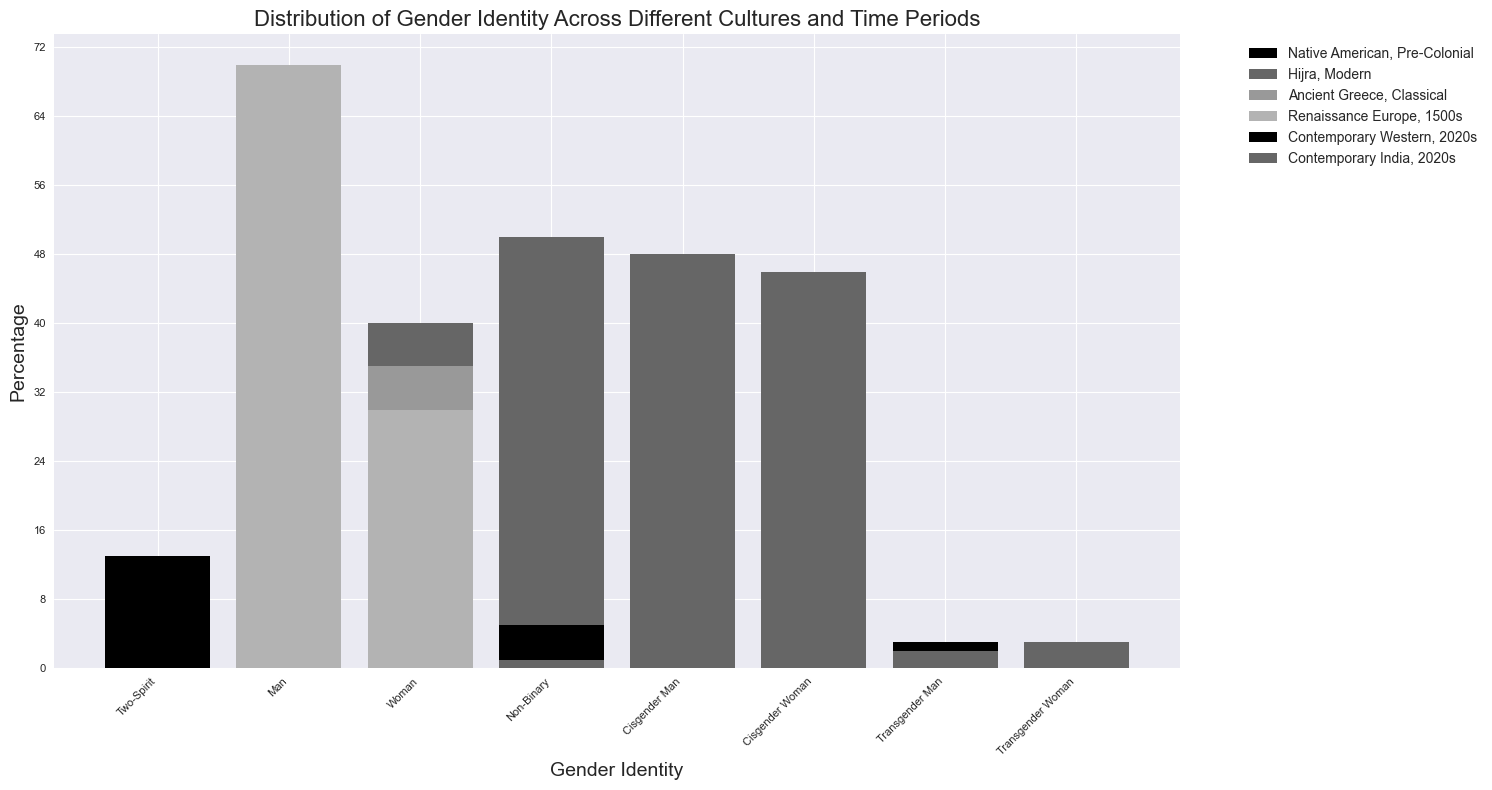What culture-time period has the highest percentage of a single gender identity? Examine the height of the bars for all categories of gender identity: the 'Man' identity in Ancient Greece (Classical period) with 65% is the highest percentage.
Answer: Ancient Greece, Classical What is the total percentage of non-binary identities across all cultures and time periods? Add the percentages for non-binary identities: Hijra (Modern) 50%, Contemporary Western (2020s) 5%, Contemporary India (2020s) 1%. The sum is 50 + 5 + 1 = 56%.
Answer: 56% Which culture-time period exhibits the most equal gender distribution between man and woman identities? Compare the bars representing 'Man' and 'Woman' within each culture and time period. Native American (Pre-Colonial) has a 57% 'Man' and 30% 'Woman' identity, Ancient Greece (Classical) has 65% 'Man' and 35% 'Woman', Renaissance Europe (1500s) has 70% 'Man' and 30% 'Woman', Contemporary Western (2020s) has 45% for both 'Cisgender Man' and 'Cisgender Woman', and Contemporary India (2020s) has 48% 'Cisgender Man' and 46% 'Cisgender Woman'. The Contemporary Western (2020s) has the most equal distribution.
Answer: Contemporary Western, 2020s How does the percentage of 'Woman' in Renaissance Europe (1500s) compare to that in Contemporary India (2020s)? For Renaissance Europe (1500s), 'Woman' is 30%. For Contemporary India (2020s), 'Cisgender Woman' is 46%. Thus, the percentage in Contemporary India (2020s) is higher.
Answer: Higher in Contemporary India, 2020s What is the average percentage of 'Transgender Man' and 'Transgender Woman' identities in Contemporary Western (2020s) and Contemporary India (2020s)? Calculate the mean percentage: Contemporary Western (2020s) 'Transgender Man' 3%, 'Transgender Woman' 2%, and Contemporary India (2020s) 'Transgender Man' 2%, 'Transgender Woman' 3%. The average is (3 + 2 + 2 + 3) / 4 = 2.5%
Answer: 2.5% Which culture-time period exhibits the most diverse range of gender identities? Count the number of unique gender identities for each culture-time period: Native American (Pre-Colonial) has 3 (Two-Spirit, Man, Woman), Hijra (Modern) has 3 (Non-Binary, Man, Woman), Ancient Greece (Classical) has 2 (Man, Woman), Renaissance Europe (1500s) has 2 (Man, Woman), Contemporary Western (2020s) has 5 (Cisgender Man, Cisgender Woman, Transgender Man, Transgender Woman, Non-Binary), and Contemporary India (2020s) has 5 (Cisgender Man, Cisgender Woman, Transgender Man, Transgender Woman, Non-Binary). Both Contemporary Western (2020s) and Contemporary India (2020s) have the most diverse range.
Answer: Contemporary Western, 2020s and Contemporary India, 2020s Between which two culture-time periods is there the greatest difference in the percentage of the 'Man' identity? Compare the 'Man' percentages across culture-time periods: Native American (Pre-Colonial) 57%, Hijra (Modern) 10%, Ancient Greece (Classical) 65%, Renaissance Europe (1500s) 70%, Contemporary Western (2020s) 45% (sum of Cisgender Man), Contemporary India (2020s) 48% (sum of Cisgender Man). The greatest difference is between Renaissance Europe (1500s) and Hijra (Modern) with a difference of
Answer: Renaissance Europe (1500s) and Hijra (Modern) What percentage of dual-gender identities (both man and woman) can be observed in Native American (Pre-Colonial) and Hijra (Modern) cultures? Sum the 'Man' and 'Woman' percentages for each: Native American (Pre-Colonial) 57% (Man) + 30% (Woman) = 87%, Hijra (Modern) 10% (Man) + 40% (Woman) = 50%. Combine these sums for the total: 87% + 50% = 137%
Answer: 137% In which culture-time period are woman identities least represented? Identify the culture-time period with the smallest percentage for 'Woman': Hijra (Modern) has 40%, Ancient Greece (Classical) has 35%, Renaissance Europe (1500s) has 30%, Native American (Pre-Colonial) has 30%, Contemporary Western (2020s) has 45% (Cisgender Woman), Contemporary India (2020s) has 46% (Cisgender Woman). The smallest percentage is found in Renaissance Europe (1500s) and Native American (Pre-Colonial), both with 30%.
Answer: Renaissance Europe, 1500s and Native American, Pre-Colonial 